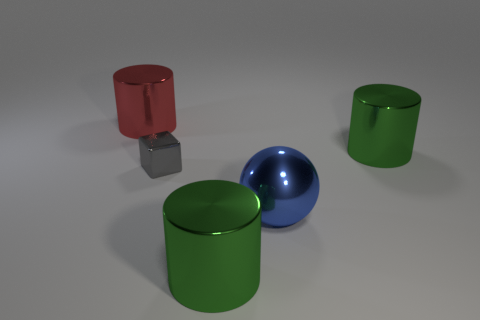Add 2 small gray blocks. How many objects exist? 7 Subtract all cylinders. How many objects are left? 2 Subtract all cubes. Subtract all cyan rubber cubes. How many objects are left? 4 Add 4 metallic balls. How many metallic balls are left? 5 Add 5 red objects. How many red objects exist? 6 Subtract 0 red blocks. How many objects are left? 5 